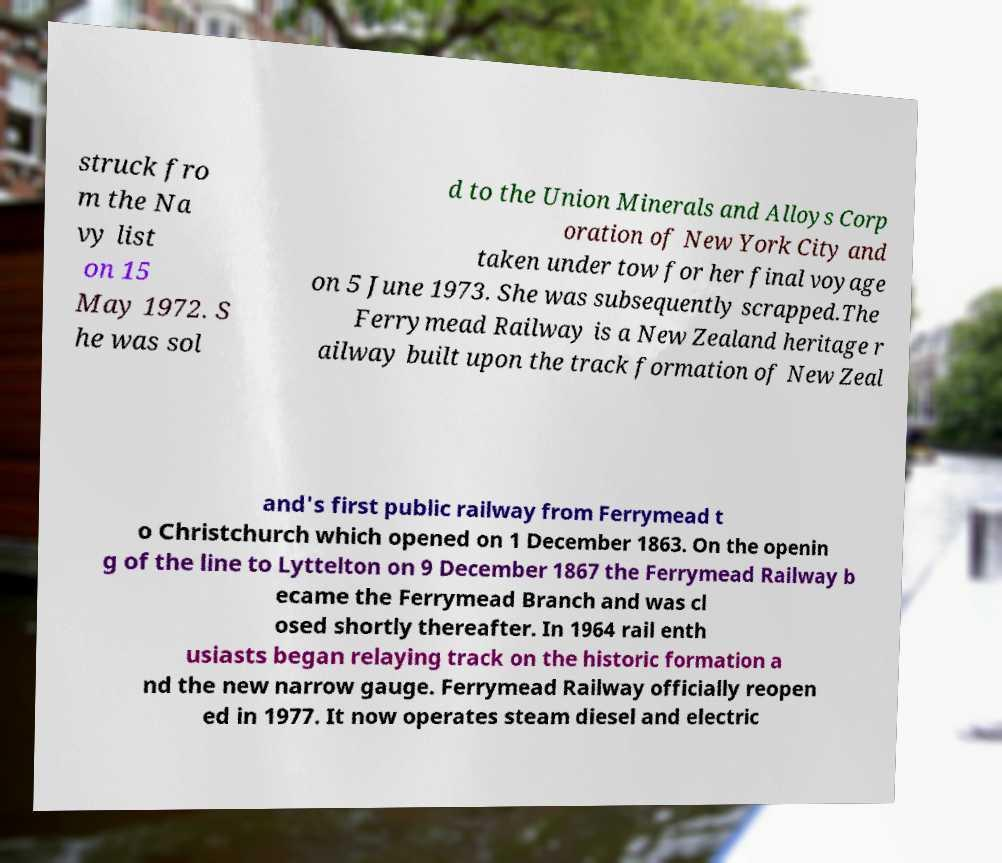Can you accurately transcribe the text from the provided image for me? struck fro m the Na vy list on 15 May 1972. S he was sol d to the Union Minerals and Alloys Corp oration of New York City and taken under tow for her final voyage on 5 June 1973. She was subsequently scrapped.The Ferrymead Railway is a New Zealand heritage r ailway built upon the track formation of New Zeal and's first public railway from Ferrymead t o Christchurch which opened on 1 December 1863. On the openin g of the line to Lyttelton on 9 December 1867 the Ferrymead Railway b ecame the Ferrymead Branch and was cl osed shortly thereafter. In 1964 rail enth usiasts began relaying track on the historic formation a nd the new narrow gauge. Ferrymead Railway officially reopen ed in 1977. It now operates steam diesel and electric 